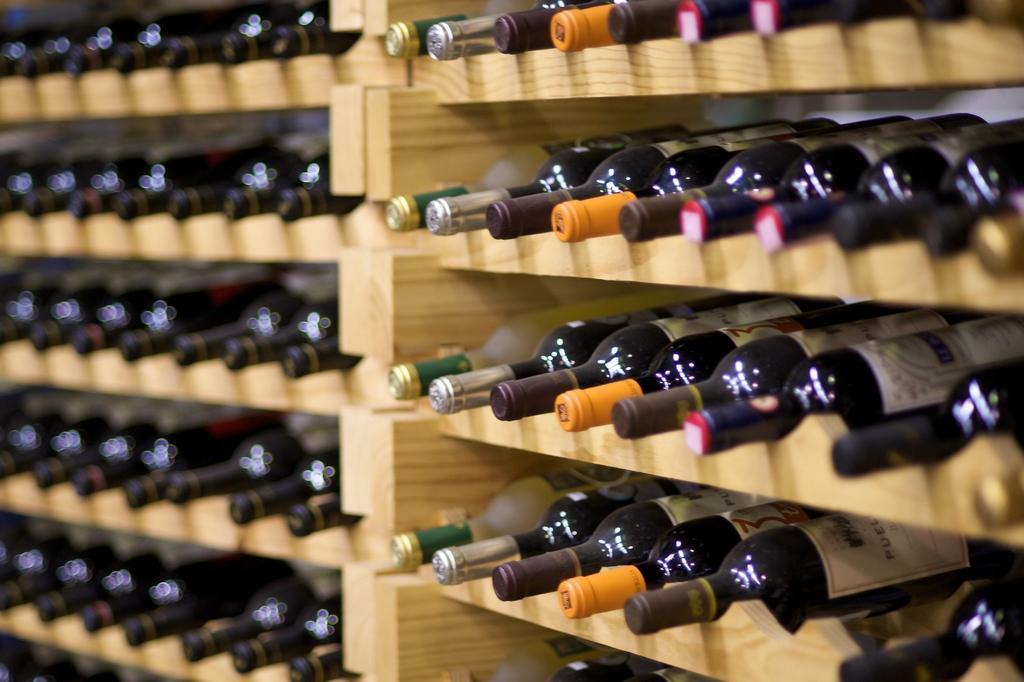How would you summarize this image in a sentence or two? In this image there are glass bottles with labels on it are arranged in an order , in the wooden shelves. 